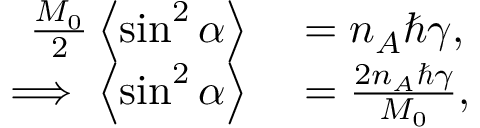<formula> <loc_0><loc_0><loc_500><loc_500>\begin{array} { r l } { \frac { M _ { 0 } } { 2 } \left \langle { \sin ^ { 2 } \alpha } \right \rangle } & = n _ { A } \hbar { \gamma } , } \\ { \implies \left \langle { \sin ^ { 2 } \alpha } \right \rangle } & = \frac { 2 n _ { A } \hbar { \gamma } } { M _ { 0 } } , } \end{array}</formula> 